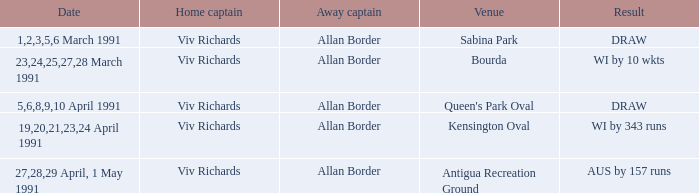In which places were the games concluded with a draw? Sabina Park, Queen's Park Oval. 